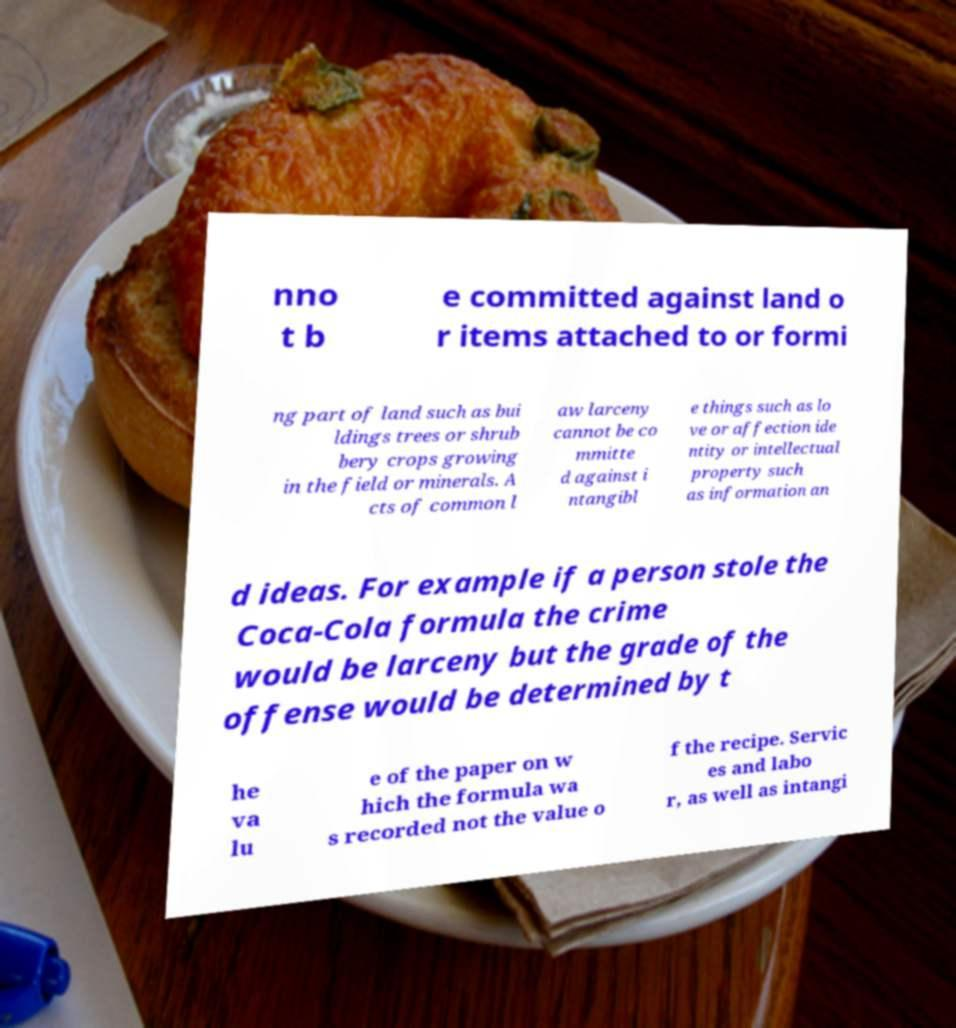What messages or text are displayed in this image? I need them in a readable, typed format. nno t b e committed against land o r items attached to or formi ng part of land such as bui ldings trees or shrub bery crops growing in the field or minerals. A cts of common l aw larceny cannot be co mmitte d against i ntangibl e things such as lo ve or affection ide ntity or intellectual property such as information an d ideas. For example if a person stole the Coca-Cola formula the crime would be larceny but the grade of the offense would be determined by t he va lu e of the paper on w hich the formula wa s recorded not the value o f the recipe. Servic es and labo r, as well as intangi 